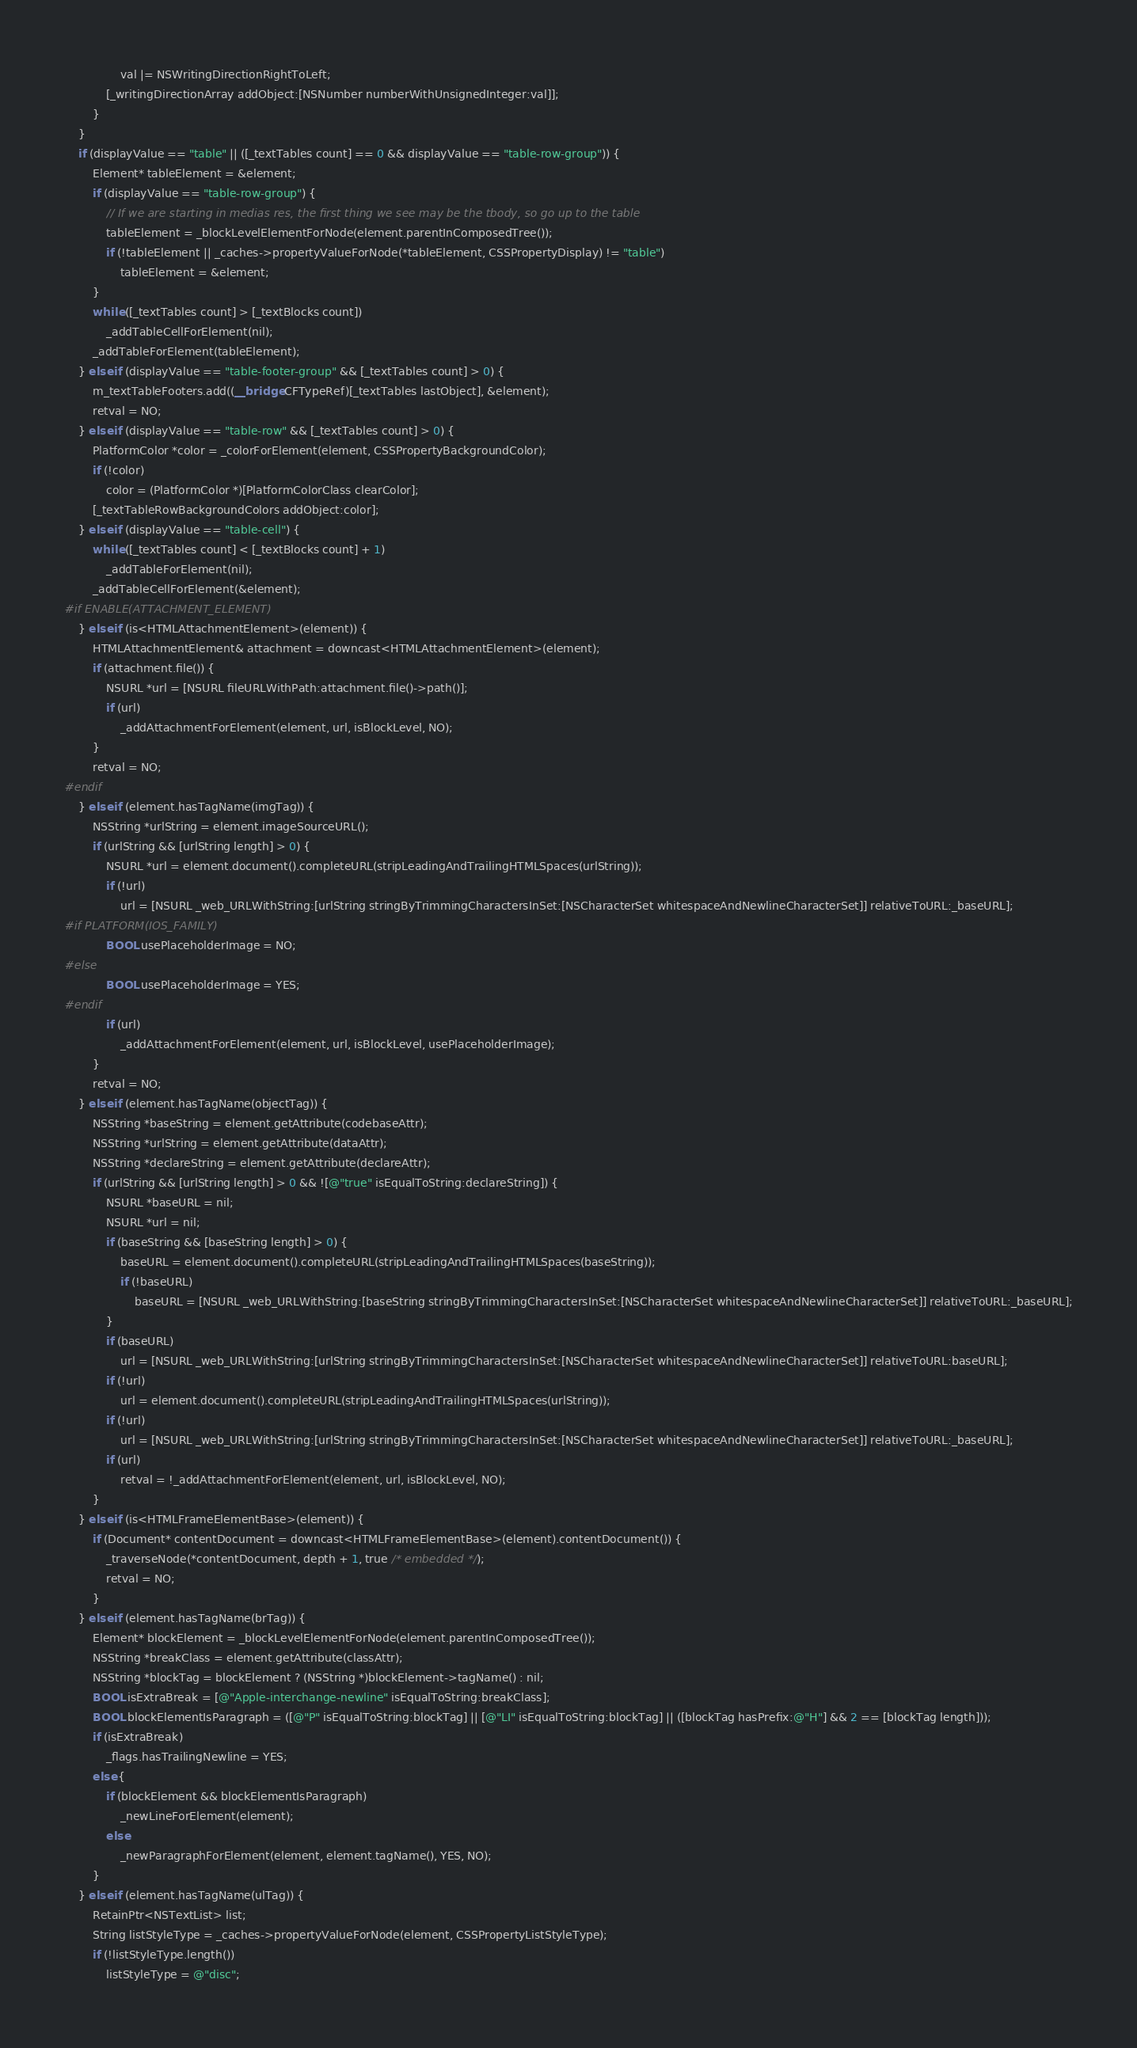<code> <loc_0><loc_0><loc_500><loc_500><_ObjectiveC_>                val |= NSWritingDirectionRightToLeft;
            [_writingDirectionArray addObject:[NSNumber numberWithUnsignedInteger:val]];
        }
    }
    if (displayValue == "table" || ([_textTables count] == 0 && displayValue == "table-row-group")) {
        Element* tableElement = &element;
        if (displayValue == "table-row-group") {
            // If we are starting in medias res, the first thing we see may be the tbody, so go up to the table
            tableElement = _blockLevelElementForNode(element.parentInComposedTree());
            if (!tableElement || _caches->propertyValueForNode(*tableElement, CSSPropertyDisplay) != "table")
                tableElement = &element;
        }
        while ([_textTables count] > [_textBlocks count])
            _addTableCellForElement(nil);
        _addTableForElement(tableElement);
    } else if (displayValue == "table-footer-group" && [_textTables count] > 0) {
        m_textTableFooters.add((__bridge CFTypeRef)[_textTables lastObject], &element);
        retval = NO;
    } else if (displayValue == "table-row" && [_textTables count] > 0) {
        PlatformColor *color = _colorForElement(element, CSSPropertyBackgroundColor);
        if (!color)
            color = (PlatformColor *)[PlatformColorClass clearColor];
        [_textTableRowBackgroundColors addObject:color];
    } else if (displayValue == "table-cell") {
        while ([_textTables count] < [_textBlocks count] + 1)
            _addTableForElement(nil);
        _addTableCellForElement(&element);
#if ENABLE(ATTACHMENT_ELEMENT)
    } else if (is<HTMLAttachmentElement>(element)) {
        HTMLAttachmentElement& attachment = downcast<HTMLAttachmentElement>(element);
        if (attachment.file()) {
            NSURL *url = [NSURL fileURLWithPath:attachment.file()->path()];
            if (url)
                _addAttachmentForElement(element, url, isBlockLevel, NO);
        }
        retval = NO;
#endif
    } else if (element.hasTagName(imgTag)) {
        NSString *urlString = element.imageSourceURL();
        if (urlString && [urlString length] > 0) {
            NSURL *url = element.document().completeURL(stripLeadingAndTrailingHTMLSpaces(urlString));
            if (!url)
                url = [NSURL _web_URLWithString:[urlString stringByTrimmingCharactersInSet:[NSCharacterSet whitespaceAndNewlineCharacterSet]] relativeToURL:_baseURL];
#if PLATFORM(IOS_FAMILY)
            BOOL usePlaceholderImage = NO;
#else
            BOOL usePlaceholderImage = YES;
#endif
            if (url)
                _addAttachmentForElement(element, url, isBlockLevel, usePlaceholderImage);
        }
        retval = NO;
    } else if (element.hasTagName(objectTag)) {
        NSString *baseString = element.getAttribute(codebaseAttr);
        NSString *urlString = element.getAttribute(dataAttr);
        NSString *declareString = element.getAttribute(declareAttr);
        if (urlString && [urlString length] > 0 && ![@"true" isEqualToString:declareString]) {
            NSURL *baseURL = nil;
            NSURL *url = nil;
            if (baseString && [baseString length] > 0) {
                baseURL = element.document().completeURL(stripLeadingAndTrailingHTMLSpaces(baseString));
                if (!baseURL)
                    baseURL = [NSURL _web_URLWithString:[baseString stringByTrimmingCharactersInSet:[NSCharacterSet whitespaceAndNewlineCharacterSet]] relativeToURL:_baseURL];
            }
            if (baseURL)
                url = [NSURL _web_URLWithString:[urlString stringByTrimmingCharactersInSet:[NSCharacterSet whitespaceAndNewlineCharacterSet]] relativeToURL:baseURL];
            if (!url)
                url = element.document().completeURL(stripLeadingAndTrailingHTMLSpaces(urlString));
            if (!url)
                url = [NSURL _web_URLWithString:[urlString stringByTrimmingCharactersInSet:[NSCharacterSet whitespaceAndNewlineCharacterSet]] relativeToURL:_baseURL];
            if (url)
                retval = !_addAttachmentForElement(element, url, isBlockLevel, NO);
        }
    } else if (is<HTMLFrameElementBase>(element)) {
        if (Document* contentDocument = downcast<HTMLFrameElementBase>(element).contentDocument()) {
            _traverseNode(*contentDocument, depth + 1, true /* embedded */);
            retval = NO;
        }
    } else if (element.hasTagName(brTag)) {
        Element* blockElement = _blockLevelElementForNode(element.parentInComposedTree());
        NSString *breakClass = element.getAttribute(classAttr);
        NSString *blockTag = blockElement ? (NSString *)blockElement->tagName() : nil;
        BOOL isExtraBreak = [@"Apple-interchange-newline" isEqualToString:breakClass];
        BOOL blockElementIsParagraph = ([@"P" isEqualToString:blockTag] || [@"LI" isEqualToString:blockTag] || ([blockTag hasPrefix:@"H"] && 2 == [blockTag length]));
        if (isExtraBreak)
            _flags.hasTrailingNewline = YES;
        else {
            if (blockElement && blockElementIsParagraph)
                _newLineForElement(element);
            else
                _newParagraphForElement(element, element.tagName(), YES, NO);
        }
    } else if (element.hasTagName(ulTag)) {
        RetainPtr<NSTextList> list;
        String listStyleType = _caches->propertyValueForNode(element, CSSPropertyListStyleType);
        if (!listStyleType.length())
            listStyleType = @"disc";</code> 